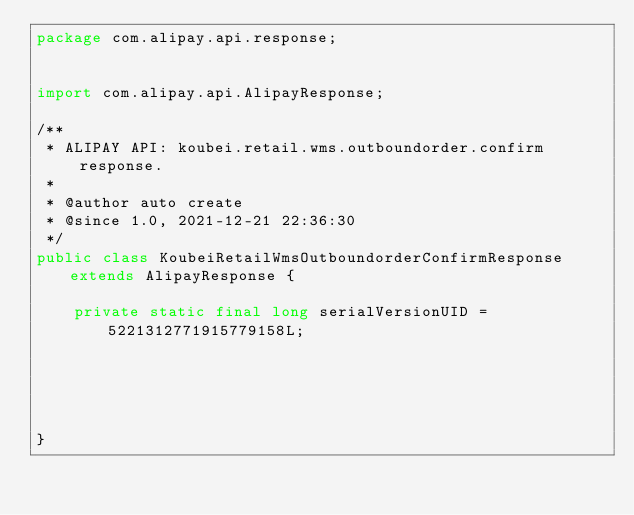Convert code to text. <code><loc_0><loc_0><loc_500><loc_500><_Java_>package com.alipay.api.response;


import com.alipay.api.AlipayResponse;

/**
 * ALIPAY API: koubei.retail.wms.outboundorder.confirm response.
 * 
 * @author auto create
 * @since 1.0, 2021-12-21 22:36:30
 */
public class KoubeiRetailWmsOutboundorderConfirmResponse extends AlipayResponse {

	private static final long serialVersionUID = 5221312771915779158L;

	

	

}
</code> 